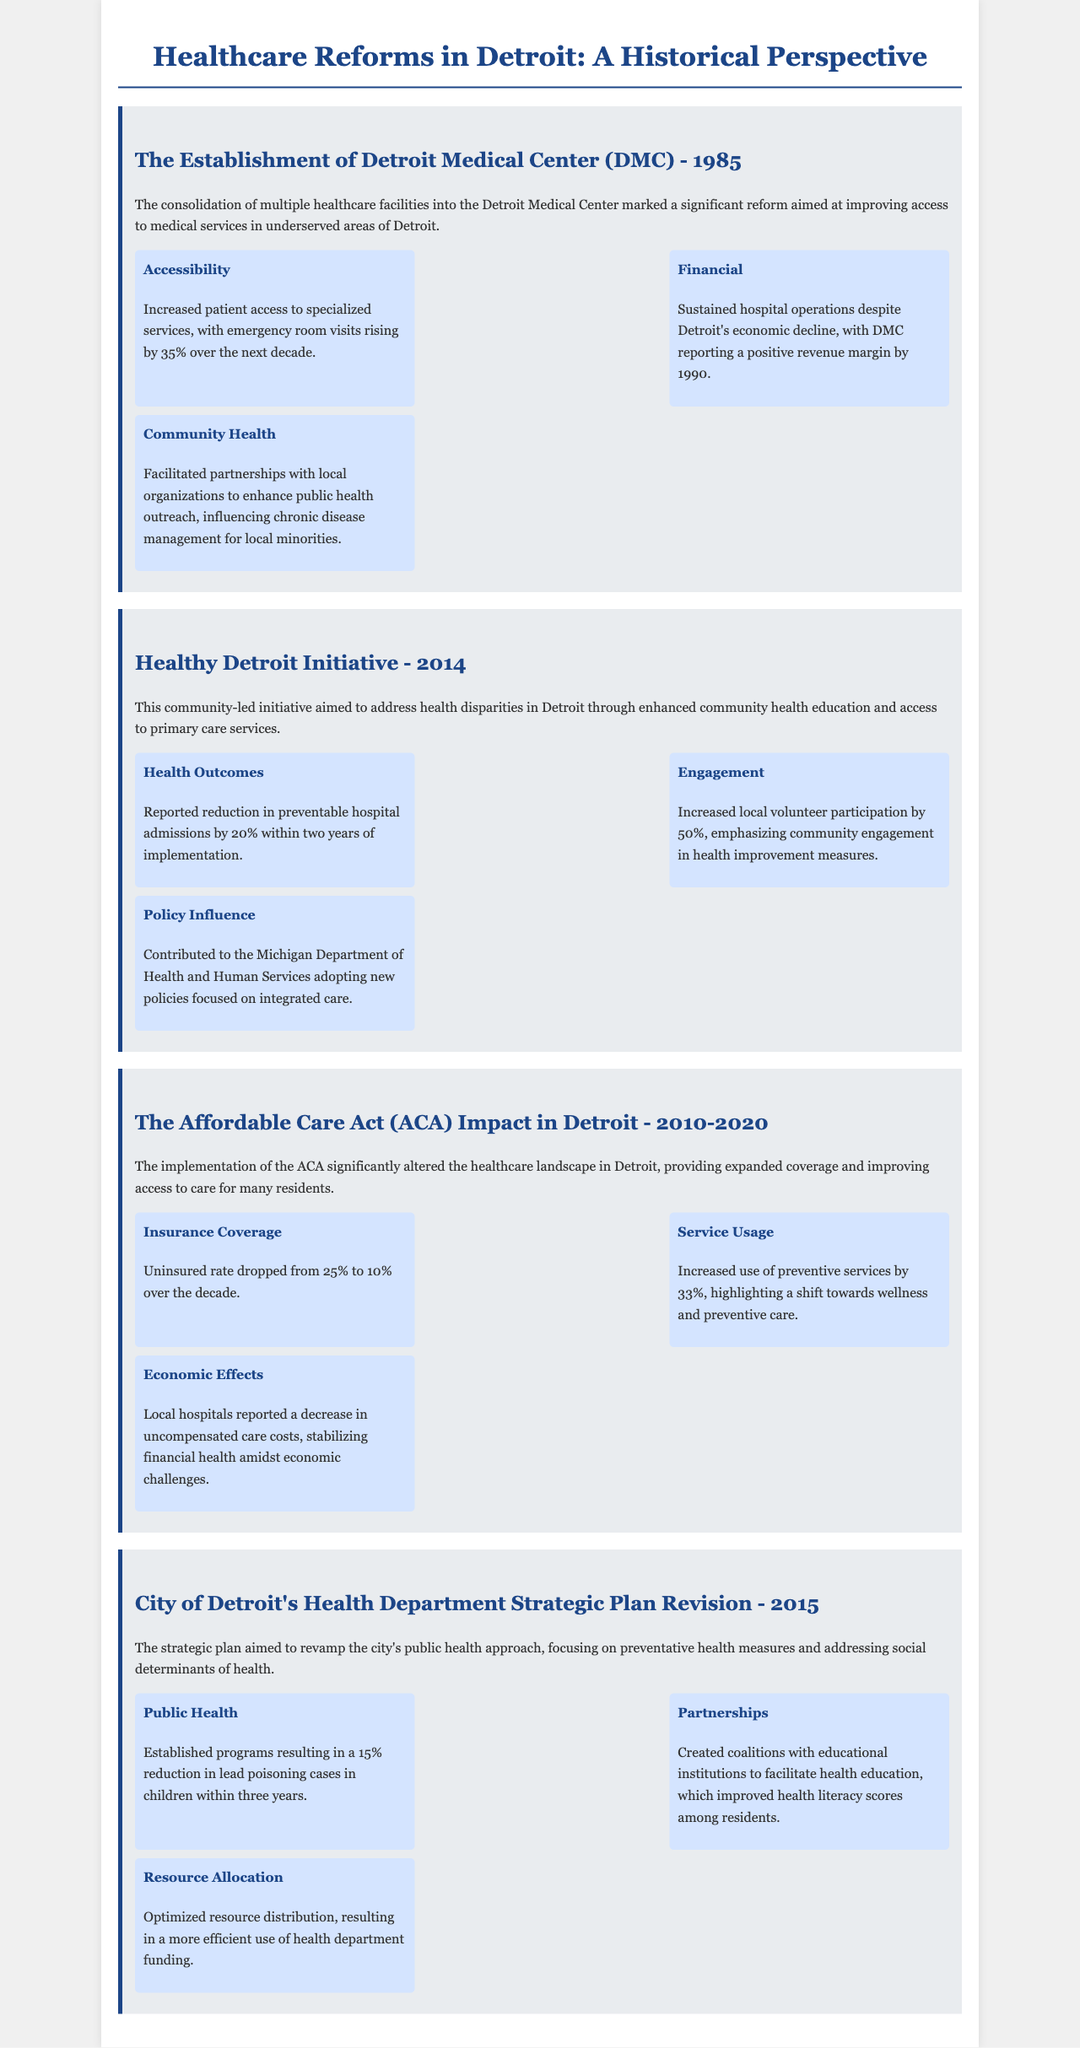What year was the Detroit Medical Center established? The document explicitly states that the Detroit Medical Center was established in 1985.
Answer: 1985 What percentage did emergency room visits rise after the DMC consolidation? The document mentions a 35% increase in emergency room visits over the next decade.
Answer: 35% What was the impact on the uninsured rate due to the ACA by 2020? The document details a drop in the uninsured rate from 25% to 10% over the decade.
Answer: 10% Which initiative aimed to address health disparities in Detroit? The document identifies the Healthy Detroit Initiative as the community-led initiative addressing health disparities.
Answer: Healthy Detroit Initiative What was the reduction in preventable hospital admissions reported for the Healthy Detroit Initiative? The document states there was a reported reduction of 20% in preventable hospital admissions within two years of implementation.
Answer: 20% How much did local volunteer participation increase due to the Healthy Detroit Initiative? According to the document, local volunteer participation increased by 50% due to the initiative.
Answer: 50% What key focus did the City of Detroit's Health Department's strategic plan revision emphasize? The document highlights that the strategic plan focused on preventative health measures and addressing social determinants of health.
Answer: Preventative health measures What percentage reduction in lead poisoning cases in children was achieved within three years? The document mentions a 15% reduction in lead poisoning cases in children as a result of new programs.
Answer: 15% What significant change occurred in local hospitals due to the ACA? The document notes a decrease in uncompensated care costs, stabilizing financial health amidst economic challenges.
Answer: Decrease in uncompensated care costs 